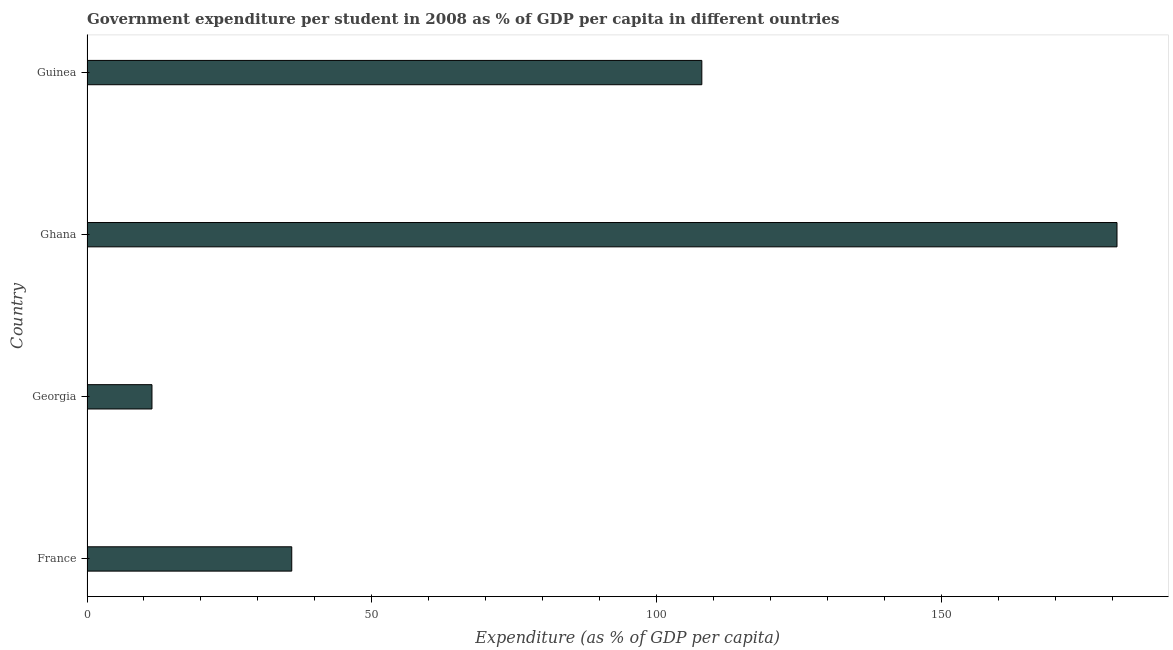Does the graph contain any zero values?
Provide a succinct answer. No. What is the title of the graph?
Your answer should be compact. Government expenditure per student in 2008 as % of GDP per capita in different ountries. What is the label or title of the X-axis?
Your answer should be compact. Expenditure (as % of GDP per capita). What is the label or title of the Y-axis?
Your answer should be compact. Country. What is the government expenditure per student in Guinea?
Offer a very short reply. 107.93. Across all countries, what is the maximum government expenditure per student?
Provide a short and direct response. 180.8. Across all countries, what is the minimum government expenditure per student?
Provide a short and direct response. 11.4. In which country was the government expenditure per student maximum?
Offer a very short reply. Ghana. In which country was the government expenditure per student minimum?
Give a very brief answer. Georgia. What is the sum of the government expenditure per student?
Provide a short and direct response. 336.08. What is the difference between the government expenditure per student in France and Ghana?
Ensure brevity in your answer.  -144.86. What is the average government expenditure per student per country?
Make the answer very short. 84.02. What is the median government expenditure per student?
Give a very brief answer. 71.93. In how many countries, is the government expenditure per student greater than 30 %?
Your answer should be very brief. 3. What is the ratio of the government expenditure per student in Georgia to that in Guinea?
Your response must be concise. 0.11. What is the difference between the highest and the second highest government expenditure per student?
Provide a short and direct response. 72.88. Is the sum of the government expenditure per student in France and Ghana greater than the maximum government expenditure per student across all countries?
Provide a succinct answer. Yes. What is the difference between the highest and the lowest government expenditure per student?
Your response must be concise. 169.4. How many countries are there in the graph?
Ensure brevity in your answer.  4. What is the difference between two consecutive major ticks on the X-axis?
Provide a short and direct response. 50. Are the values on the major ticks of X-axis written in scientific E-notation?
Make the answer very short. No. What is the Expenditure (as % of GDP per capita) in France?
Your answer should be very brief. 35.94. What is the Expenditure (as % of GDP per capita) of Georgia?
Ensure brevity in your answer.  11.4. What is the Expenditure (as % of GDP per capita) of Ghana?
Offer a terse response. 180.8. What is the Expenditure (as % of GDP per capita) in Guinea?
Make the answer very short. 107.93. What is the difference between the Expenditure (as % of GDP per capita) in France and Georgia?
Offer a very short reply. 24.54. What is the difference between the Expenditure (as % of GDP per capita) in France and Ghana?
Provide a succinct answer. -144.86. What is the difference between the Expenditure (as % of GDP per capita) in France and Guinea?
Offer a terse response. -71.98. What is the difference between the Expenditure (as % of GDP per capita) in Georgia and Ghana?
Offer a terse response. -169.4. What is the difference between the Expenditure (as % of GDP per capita) in Georgia and Guinea?
Offer a very short reply. -96.52. What is the difference between the Expenditure (as % of GDP per capita) in Ghana and Guinea?
Your answer should be compact. 72.88. What is the ratio of the Expenditure (as % of GDP per capita) in France to that in Georgia?
Give a very brief answer. 3.15. What is the ratio of the Expenditure (as % of GDP per capita) in France to that in Ghana?
Your answer should be compact. 0.2. What is the ratio of the Expenditure (as % of GDP per capita) in France to that in Guinea?
Provide a succinct answer. 0.33. What is the ratio of the Expenditure (as % of GDP per capita) in Georgia to that in Ghana?
Provide a short and direct response. 0.06. What is the ratio of the Expenditure (as % of GDP per capita) in Georgia to that in Guinea?
Provide a short and direct response. 0.11. What is the ratio of the Expenditure (as % of GDP per capita) in Ghana to that in Guinea?
Your answer should be compact. 1.68. 